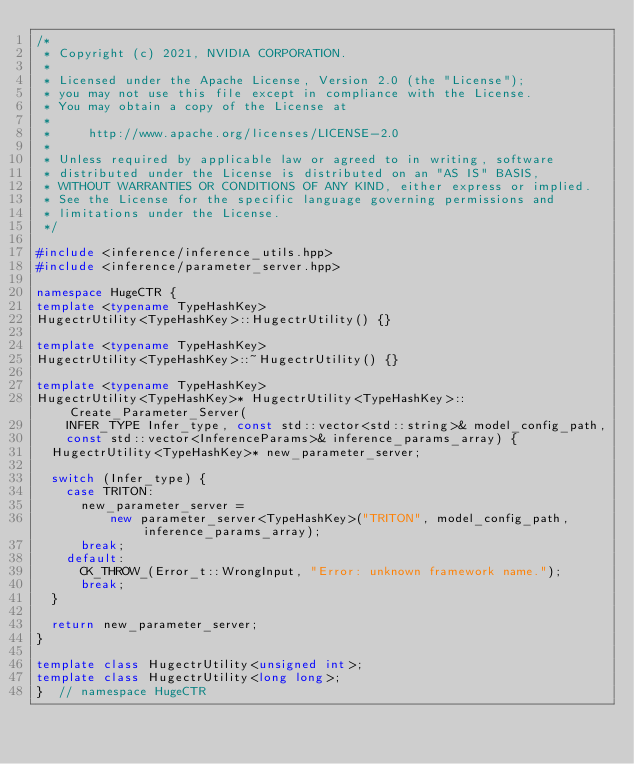Convert code to text. <code><loc_0><loc_0><loc_500><loc_500><_C++_>/*
 * Copyright (c) 2021, NVIDIA CORPORATION.
 *
 * Licensed under the Apache License, Version 2.0 (the "License");
 * you may not use this file except in compliance with the License.
 * You may obtain a copy of the License at
 *
 *     http://www.apache.org/licenses/LICENSE-2.0
 *
 * Unless required by applicable law or agreed to in writing, software
 * distributed under the License is distributed on an "AS IS" BASIS,
 * WITHOUT WARRANTIES OR CONDITIONS OF ANY KIND, either express or implied.
 * See the License for the specific language governing permissions and
 * limitations under the License.
 */

#include <inference/inference_utils.hpp>
#include <inference/parameter_server.hpp>

namespace HugeCTR {
template <typename TypeHashKey>
HugectrUtility<TypeHashKey>::HugectrUtility() {}

template <typename TypeHashKey>
HugectrUtility<TypeHashKey>::~HugectrUtility() {}

template <typename TypeHashKey>
HugectrUtility<TypeHashKey>* HugectrUtility<TypeHashKey>::Create_Parameter_Server(
    INFER_TYPE Infer_type, const std::vector<std::string>& model_config_path,
    const std::vector<InferenceParams>& inference_params_array) {
  HugectrUtility<TypeHashKey>* new_parameter_server;

  switch (Infer_type) {
    case TRITON:
      new_parameter_server =
          new parameter_server<TypeHashKey>("TRITON", model_config_path, inference_params_array);
      break;
    default:
      CK_THROW_(Error_t::WrongInput, "Error: unknown framework name.");
      break;
  }

  return new_parameter_server;
}

template class HugectrUtility<unsigned int>;
template class HugectrUtility<long long>;
}  // namespace HugeCTR
</code> 